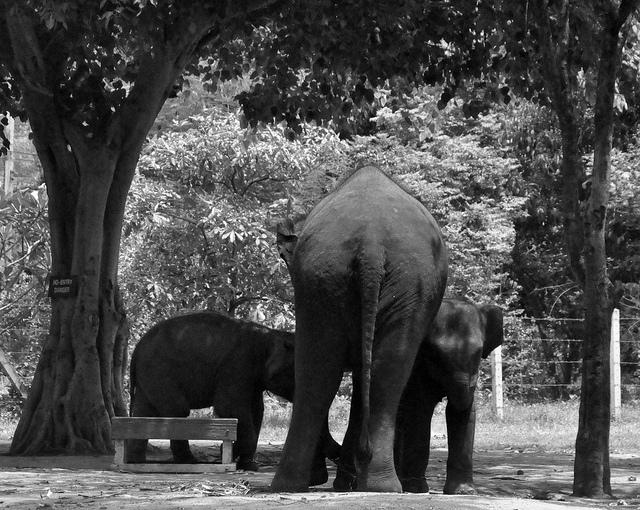What type of animal is this?
Short answer required. Elephant. Is this a colorful picture?
Write a very short answer. No. How many elephants are in the picture?
Keep it brief. 3. 